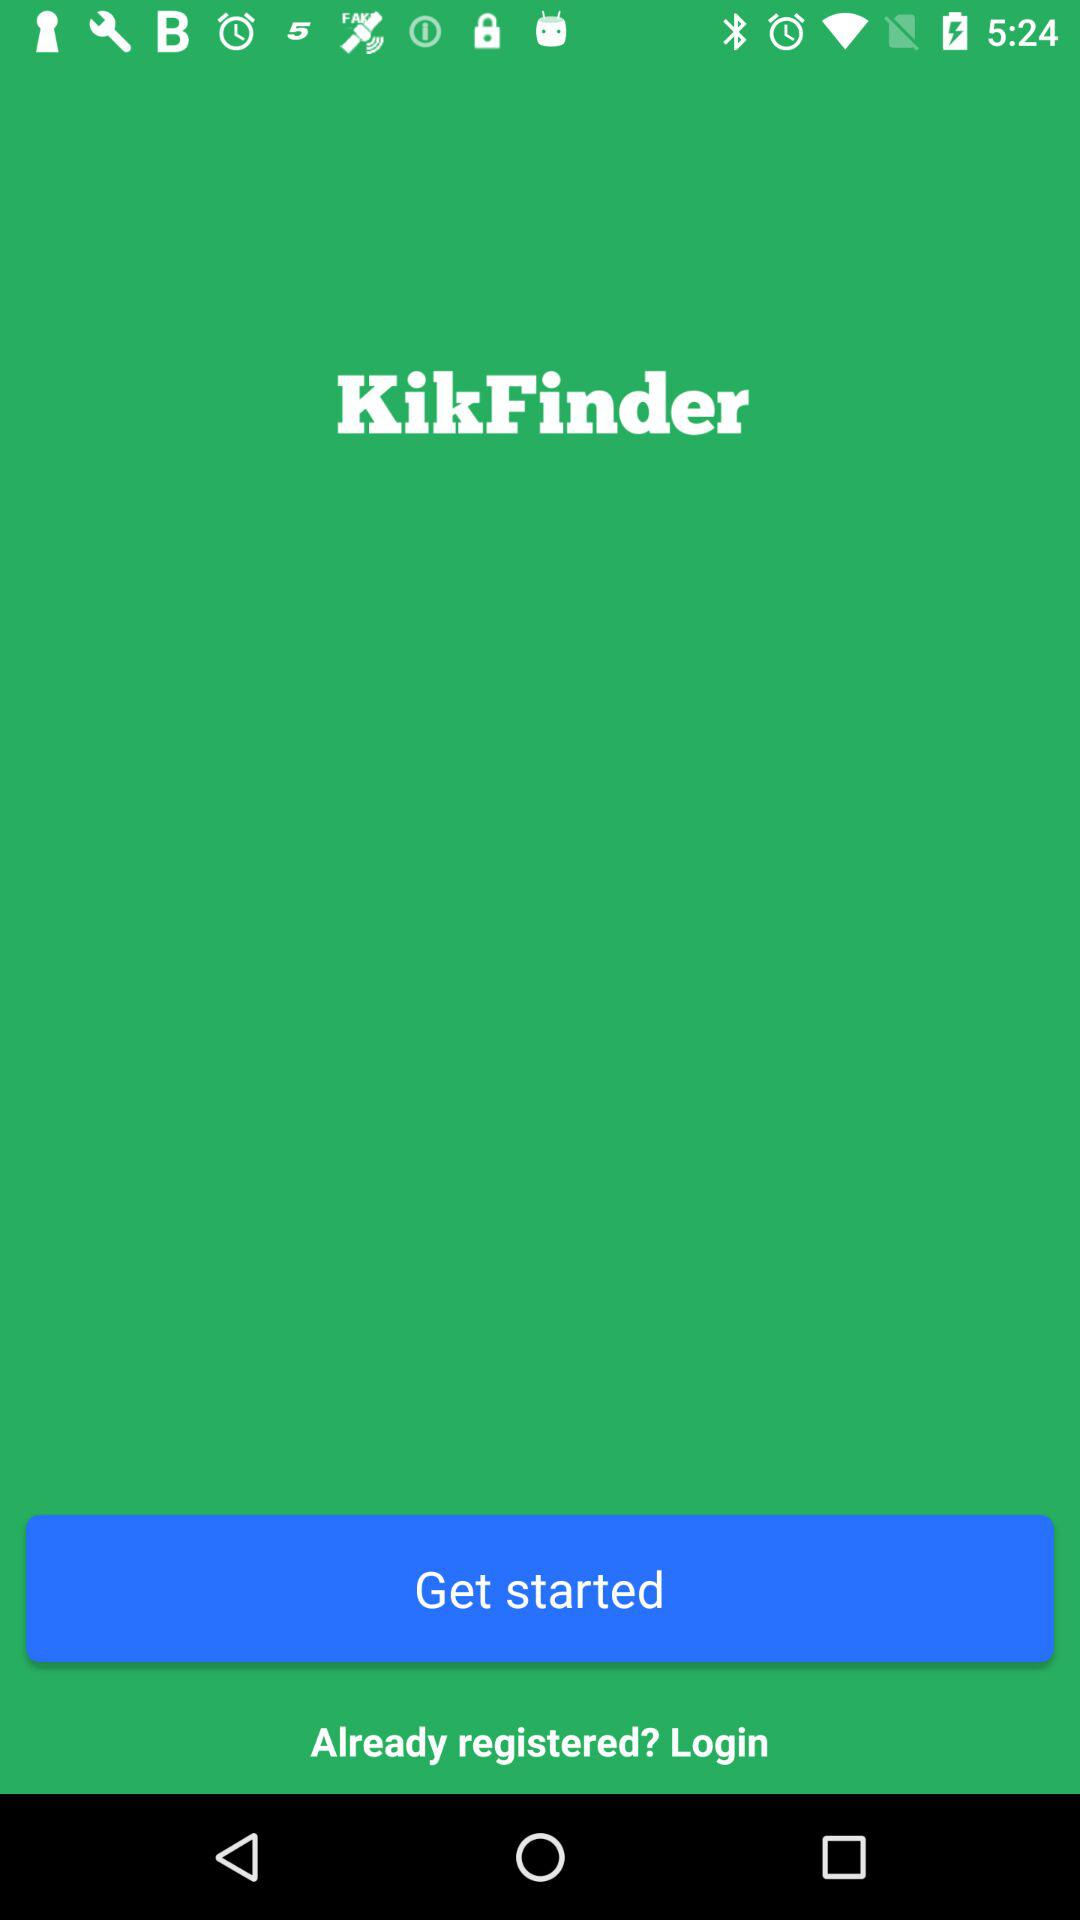How long does it take to log in?
When the provided information is insufficient, respond with <no answer>. <no answer> 